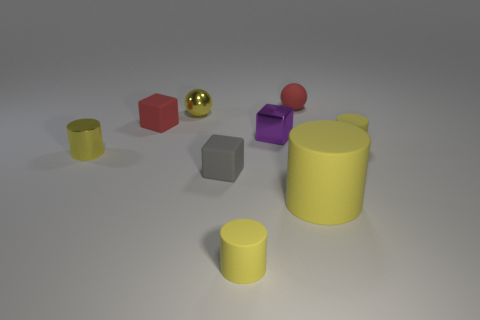How many yellow cylinders must be subtracted to get 1 yellow cylinders? 3 Subtract all small cylinders. How many cylinders are left? 1 Subtract all red cubes. How many cubes are left? 2 Subtract all balls. How many objects are left? 7 Add 1 yellow objects. How many objects exist? 10 Add 7 small gray rubber things. How many small gray rubber things exist? 8 Subtract 0 brown blocks. How many objects are left? 9 Subtract 2 spheres. How many spheres are left? 0 Subtract all gray cylinders. Subtract all gray blocks. How many cylinders are left? 4 Subtract all gray balls. How many blue cubes are left? 0 